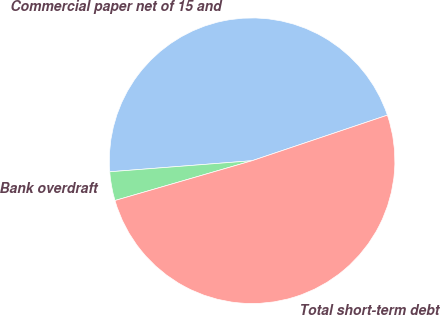Convert chart. <chart><loc_0><loc_0><loc_500><loc_500><pie_chart><fcel>Commercial paper net of 15 and<fcel>Bank overdraft<fcel>Total short-term debt<nl><fcel>46.07%<fcel>3.26%<fcel>50.68%<nl></chart> 